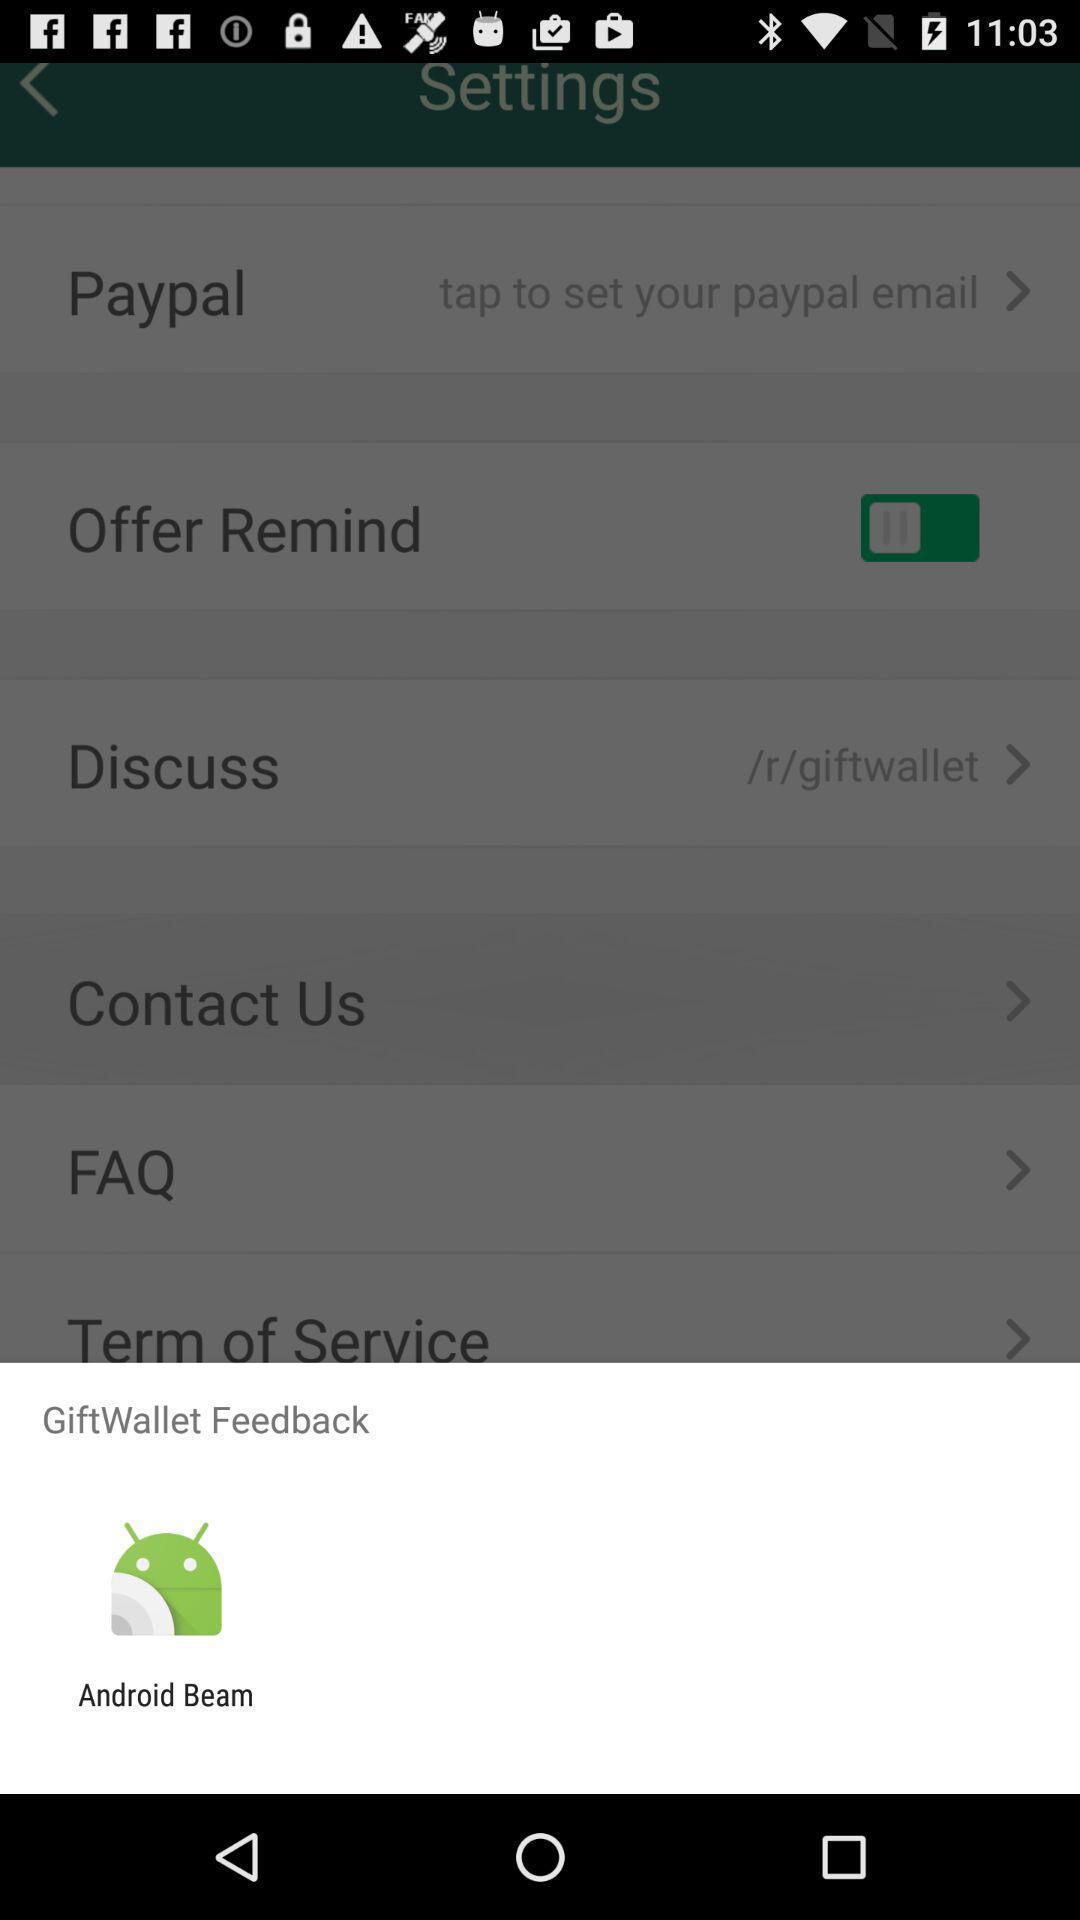What details can you identify in this image? Popup showing about android beam. 